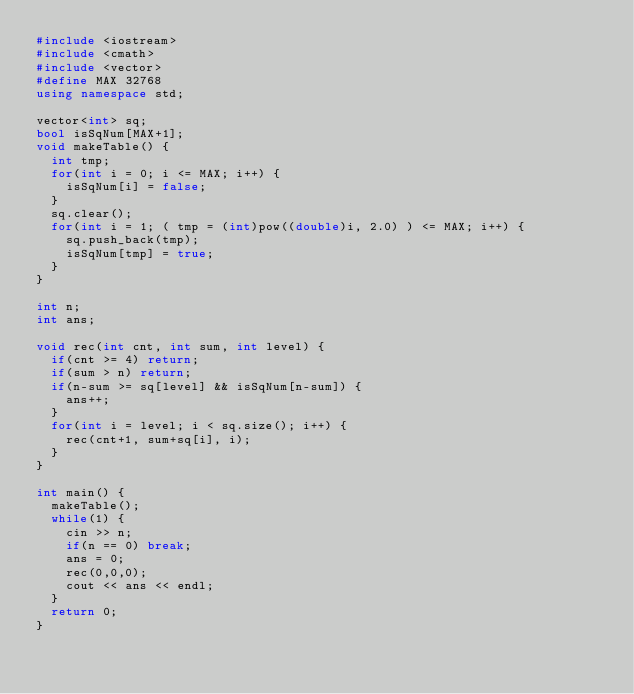<code> <loc_0><loc_0><loc_500><loc_500><_C++_>#include <iostream>
#include <cmath>
#include <vector>
#define MAX 32768
using namespace std;

vector<int> sq;
bool isSqNum[MAX+1];
void makeTable() {
  int tmp;
  for(int i = 0; i <= MAX; i++) {
    isSqNum[i] = false;
  }
  sq.clear();
  for(int i = 1; ( tmp = (int)pow((double)i, 2.0) ) <= MAX; i++) {
    sq.push_back(tmp);
    isSqNum[tmp] = true;
  }
}

int n;
int ans;

void rec(int cnt, int sum, int level) {
  if(cnt >= 4) return;
  if(sum > n) return;
  if(n-sum >= sq[level] && isSqNum[n-sum]) {
    ans++;
  }
  for(int i = level; i < sq.size(); i++) {
    rec(cnt+1, sum+sq[i], i);
  }
}

int main() {
  makeTable();
  while(1) {
    cin >> n;
    if(n == 0) break;
    ans = 0;
    rec(0,0,0);
    cout << ans << endl;
  }
  return 0;
}</code> 